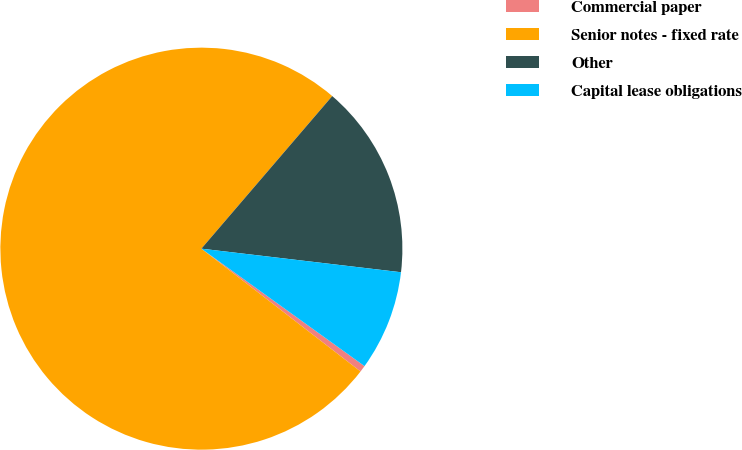Convert chart. <chart><loc_0><loc_0><loc_500><loc_500><pie_chart><fcel>Commercial paper<fcel>Senior notes - fixed rate<fcel>Other<fcel>Capital lease obligations<nl><fcel>0.53%<fcel>75.82%<fcel>15.59%<fcel>8.06%<nl></chart> 